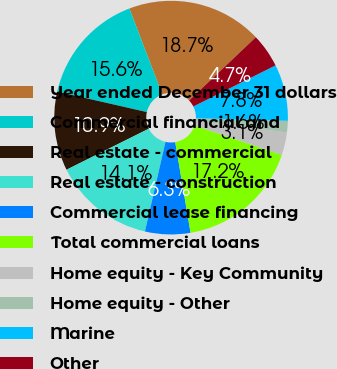<chart> <loc_0><loc_0><loc_500><loc_500><pie_chart><fcel>Year ended December 31 dollars<fcel>Commercial financial and<fcel>Real estate - commercial<fcel>Real estate - construction<fcel>Commercial lease financing<fcel>Total commercial loans<fcel>Home equity - Key Community<fcel>Home equity - Other<fcel>Marine<fcel>Other<nl><fcel>18.73%<fcel>15.61%<fcel>10.94%<fcel>14.05%<fcel>6.26%<fcel>17.17%<fcel>3.14%<fcel>1.58%<fcel>7.82%<fcel>4.7%<nl></chart> 